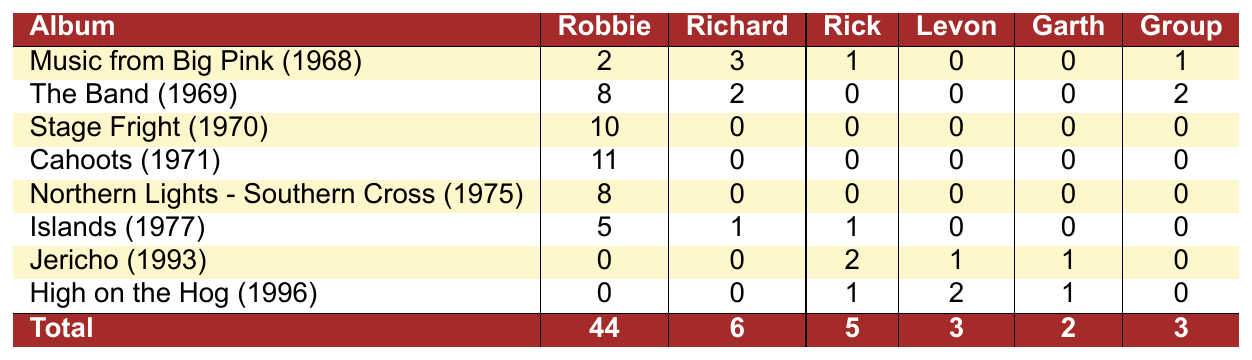What is the total number of songwriting credits for Robbie Robertson? By looking at the "Robbie Robertson" column in the table and summing the values across all albums, we have 2 + 8 + 10 + 11 + 8 + 5 + 0 + 0 = 44.
Answer: 44 Which album has the highest number of songwriting credits by Richard Manuel? From the "Richard Manuel" column, "Music from Big Pink (1968)" has the highest value of 3, while all other albums have either 0 or lower values.
Answer: Music from Big Pink (1968) Did Levon Helm contribute any songwriting credits to the album "Cahoots"? Checking the "Levon Helm" column for the album "Cahoots (1971)", the value is 0, indicating he did not contribute any credits.
Answer: No How many total songwriting credits did the group compose collectively across all albums? By looking at the "Group Composition" column, we sum the values: 1 + 2 + 0 + 0 + 0 + 0 + 0 + 0 = 3.
Answer: 3 Which member had the least contributions across all albums? By reviewing the total contributions for each member: Richard Manuel (6), Rick Danko (5), Levon Helm (3), Garth Hudson (2). Garth Hudson has the least overall with 2.
Answer: Garth Hudson What is the average number of songwriting credits for Rick Danko across the albums? Summing Rick Danko's contributions gives us 1 + 0 + 0 + 0 + 0 + 1 + 2 + 1 = 5. There are 8 albums, so the average is 5/8 = 0.625.
Answer: 0.625 Which album has the most songwriting credits contributed solely by Robbie Robertson? Examining the "Robbie Robertson" column, "Cahoots (1971)" has the highest value of 11, which is the most significant contribution.
Answer: Cahoots (1971) Is there any album where Richard Manuel and Garth Hudson contributed songwriting credits together? Looking for overlaps in the columns for Richard Manuel and Garth Hudson across the albums, we find that both have contributions of 0 together in all instances.
Answer: No 